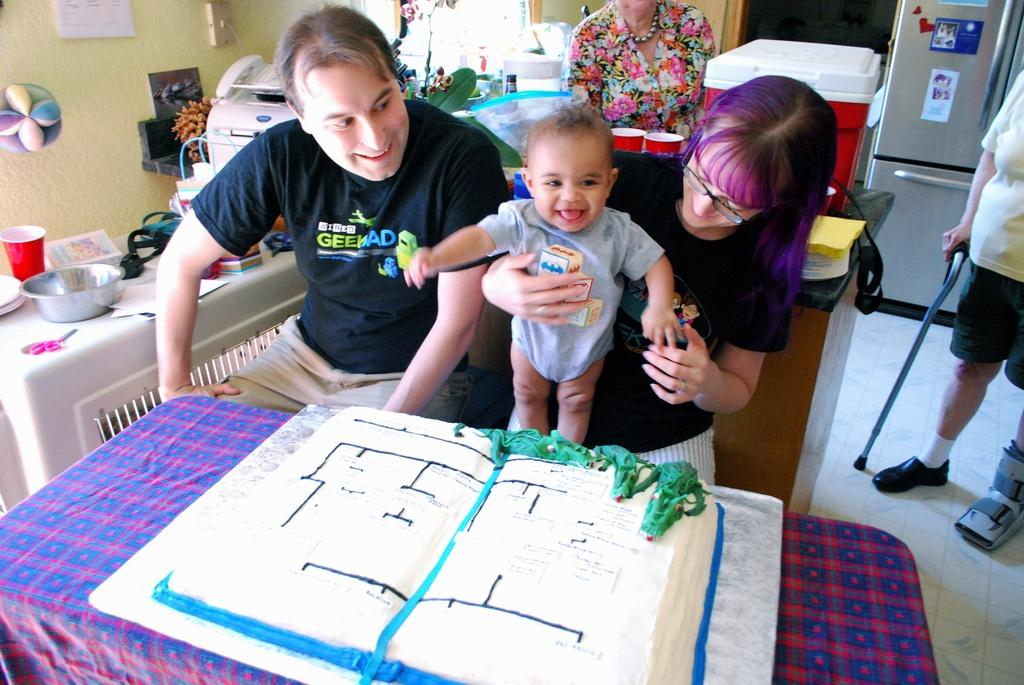What are the people in the image doing? The people in the image are sitting on chairs. Are there any other people visible in the image? Yes, there are people standing in the background of the image. What is on the table in the image? There is a cake on the table. What might be used for serving or eating the cake? The table in the image suggests that it could be used for serving or eating the cake. What type of shoes can be seen on the horse in the image? There is no horse present in the image, so there are no shoes to be seen on a horse. 